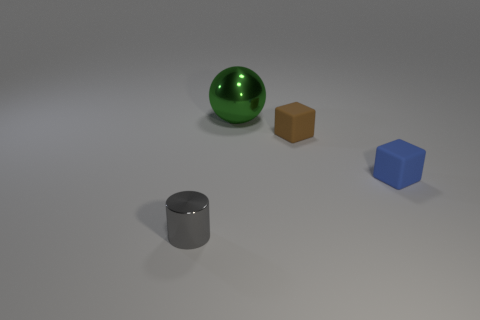Add 3 large matte things. How many objects exist? 7 Subtract all brown cubes. How many cubes are left? 1 Subtract all spheres. How many objects are left? 3 Subtract 1 cylinders. How many cylinders are left? 0 Subtract all blue cylinders. Subtract all blue blocks. How many cylinders are left? 1 Subtract all yellow cylinders. How many blue cubes are left? 1 Subtract all tiny yellow metal cubes. Subtract all large green metallic balls. How many objects are left? 3 Add 1 tiny metal cylinders. How many tiny metal cylinders are left? 2 Add 2 gray metallic cylinders. How many gray metallic cylinders exist? 3 Subtract 0 yellow cylinders. How many objects are left? 4 